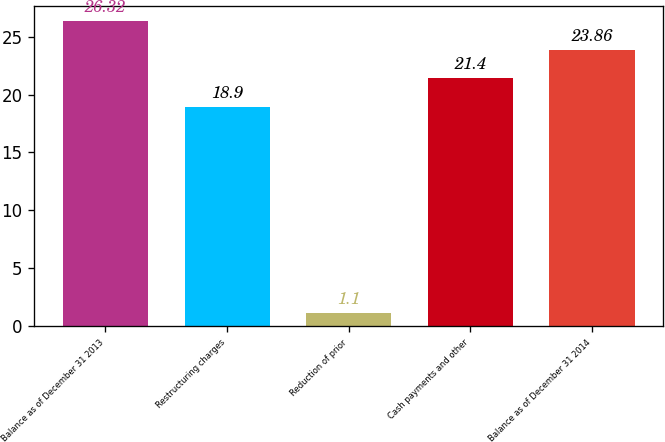Convert chart to OTSL. <chart><loc_0><loc_0><loc_500><loc_500><bar_chart><fcel>Balance as of December 31 2013<fcel>Restructuring charges<fcel>Reduction of prior<fcel>Cash payments and other<fcel>Balance as of December 31 2014<nl><fcel>26.32<fcel>18.9<fcel>1.1<fcel>21.4<fcel>23.86<nl></chart> 